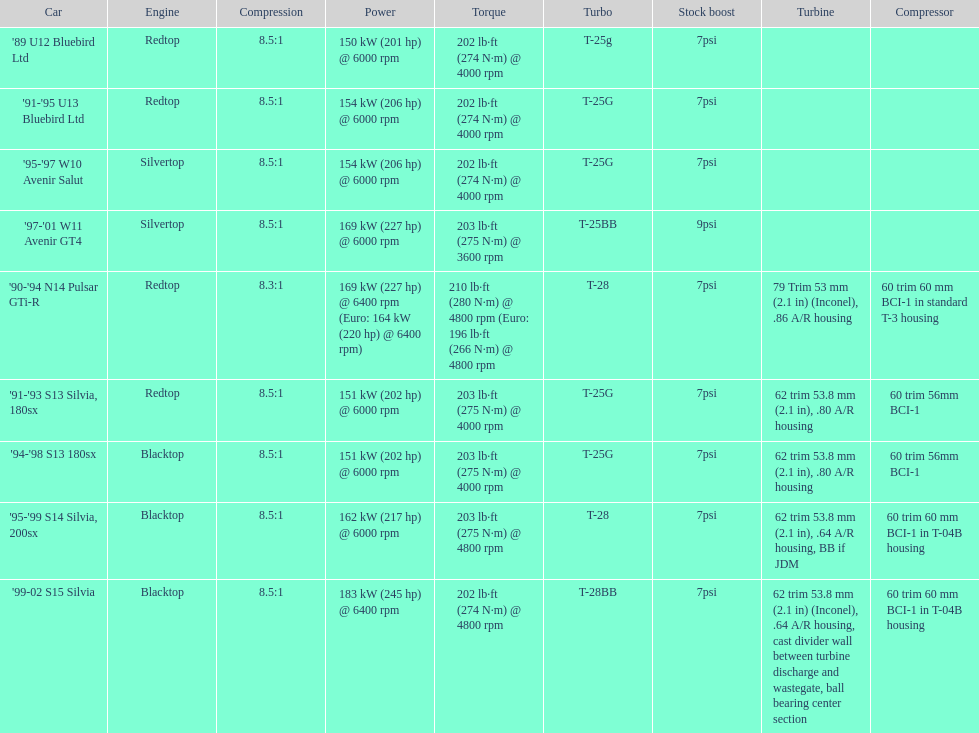How many models utilized the redtop engine? 4. 